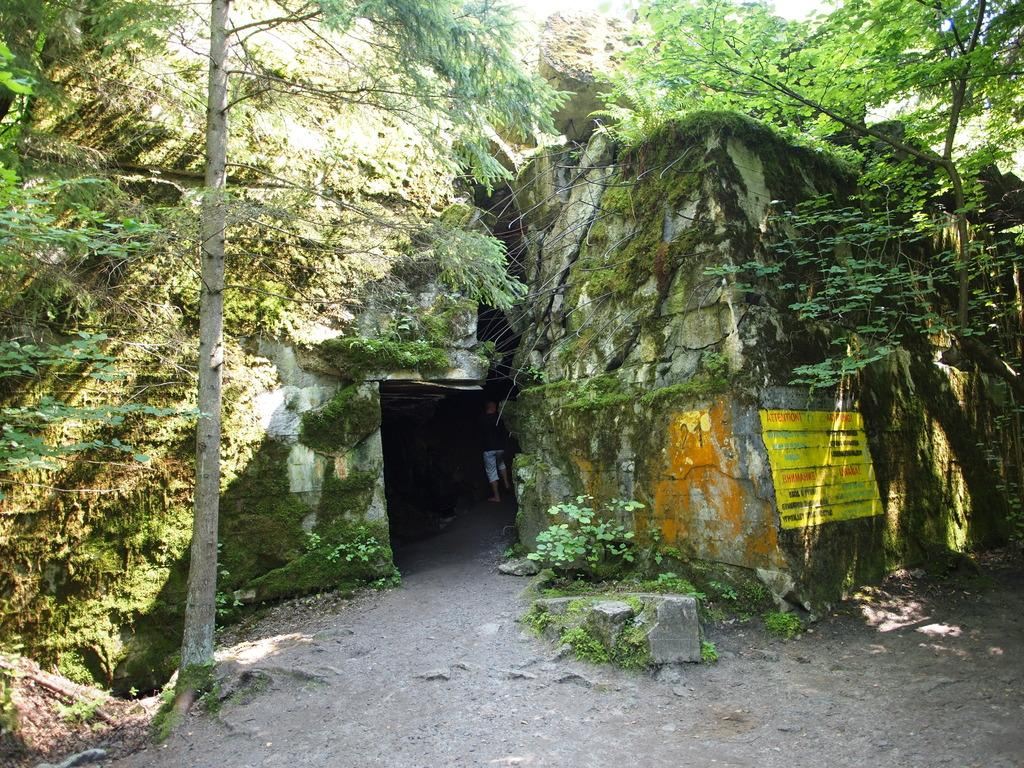What type of natural formation is visible in the image? There is a cave in the image. What can be seen on the right side of the image? There are trees on the right side of the image. What can be seen on the left side of the image? There are trees on the left side of the image. What type of drain is visible in the image? There is no drain present in the image. Is there a writer in the image? There is no writer present in the image. 